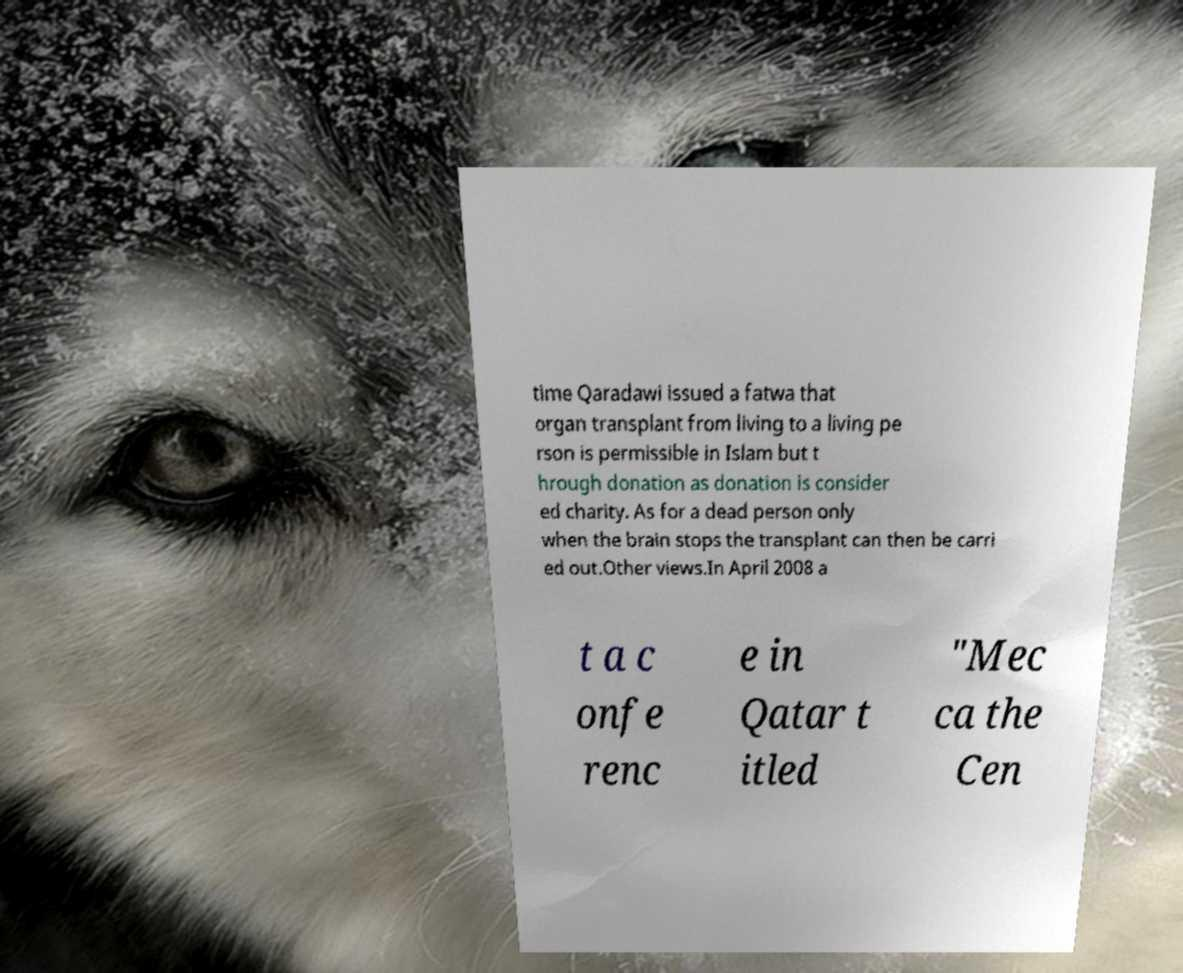Could you extract and type out the text from this image? time Qaradawi issued a fatwa that organ transplant from living to a living pe rson is permissible in Islam but t hrough donation as donation is consider ed charity. As for a dead person only when the brain stops the transplant can then be carri ed out.Other views.In April 2008 a t a c onfe renc e in Qatar t itled "Mec ca the Cen 